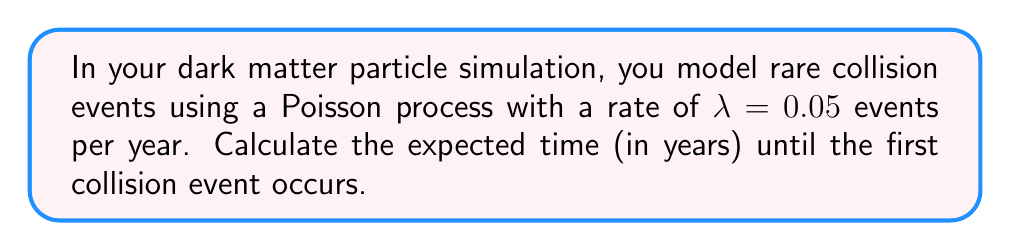Could you help me with this problem? To solve this problem, we'll use the properties of Poisson processes:

1) In a Poisson process, the time until the first event occurs follows an exponential distribution with parameter $\lambda$.

2) For an exponential distribution with parameter $\lambda$, the expected value (mean) is given by $\frac{1}{\lambda}$.

3) In this case, $\lambda = 0.05$ events per year.

4) Therefore, the expected time until the first collision event is:

   $$E[T] = \frac{1}{\lambda} = \frac{1}{0.05} = 20$$

5) This means we expect the first collision event to occur, on average, after 20 years.
Answer: 20 years 